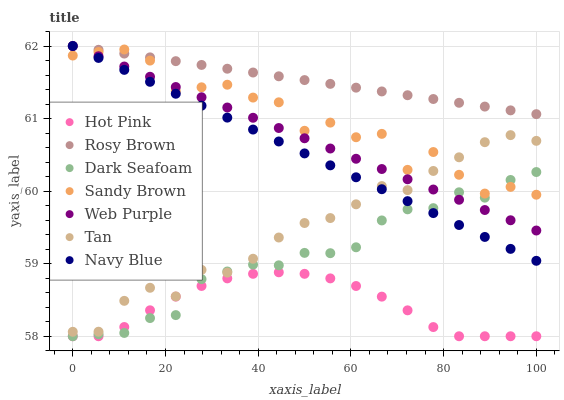Does Hot Pink have the minimum area under the curve?
Answer yes or no. Yes. Does Rosy Brown have the maximum area under the curve?
Answer yes or no. Yes. Does Navy Blue have the minimum area under the curve?
Answer yes or no. No. Does Navy Blue have the maximum area under the curve?
Answer yes or no. No. Is Rosy Brown the smoothest?
Answer yes or no. Yes. Is Sandy Brown the roughest?
Answer yes or no. Yes. Is Navy Blue the smoothest?
Answer yes or no. No. Is Navy Blue the roughest?
Answer yes or no. No. Does Hot Pink have the lowest value?
Answer yes or no. Yes. Does Navy Blue have the lowest value?
Answer yes or no. No. Does Web Purple have the highest value?
Answer yes or no. Yes. Does Dark Seafoam have the highest value?
Answer yes or no. No. Is Hot Pink less than Navy Blue?
Answer yes or no. Yes. Is Tan greater than Hot Pink?
Answer yes or no. Yes. Does Dark Seafoam intersect Sandy Brown?
Answer yes or no. Yes. Is Dark Seafoam less than Sandy Brown?
Answer yes or no. No. Is Dark Seafoam greater than Sandy Brown?
Answer yes or no. No. Does Hot Pink intersect Navy Blue?
Answer yes or no. No. 